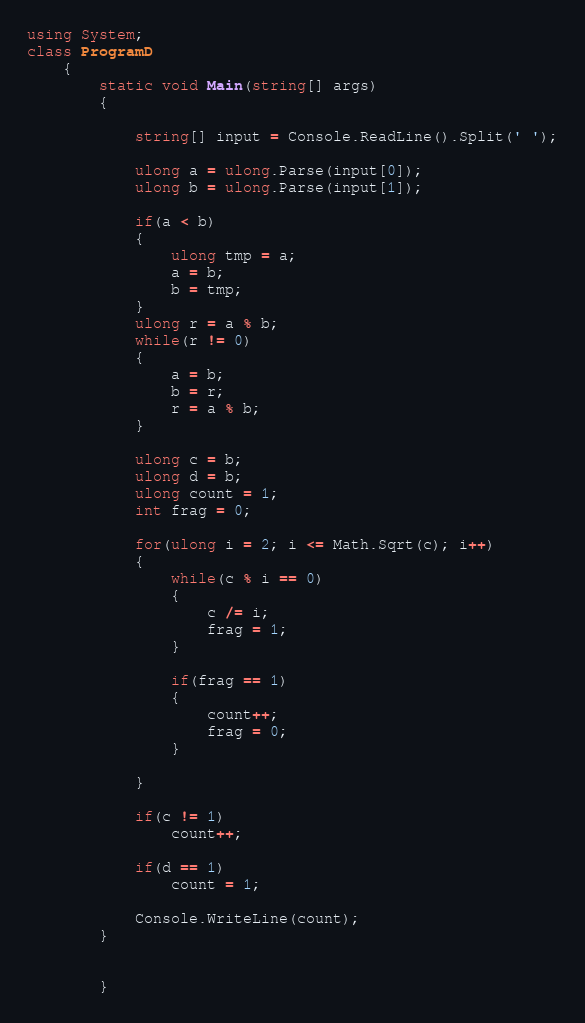Convert code to text. <code><loc_0><loc_0><loc_500><loc_500><_C#_>using System;
class ProgramD
    {
        static void Main(string[] args)
        {

            string[] input = Console.ReadLine().Split(' ');

            ulong a = ulong.Parse(input[0]);
            ulong b = ulong.Parse(input[1]);

            if(a < b)
            {
                ulong tmp = a;
                a = b;
                b = tmp;
            }
            ulong r = a % b;
            while(r != 0)
            {
                a = b;
                b = r;
                r = a % b;
            }

            ulong c = b;
            ulong d = b;
            ulong count = 1;
            int frag = 0;

            for(ulong i = 2; i <= Math.Sqrt(c); i++)
            {
                while(c % i == 0)
                {
                    c /= i;
                    frag = 1;
                }

                if(frag == 1)
                {
                    count++;
                    frag = 0;
                }  

            }
            
            if(c != 1)
                count++;
          
            if(d == 1)
                count = 1;

            Console.WriteLine(count);
        }


        }</code> 